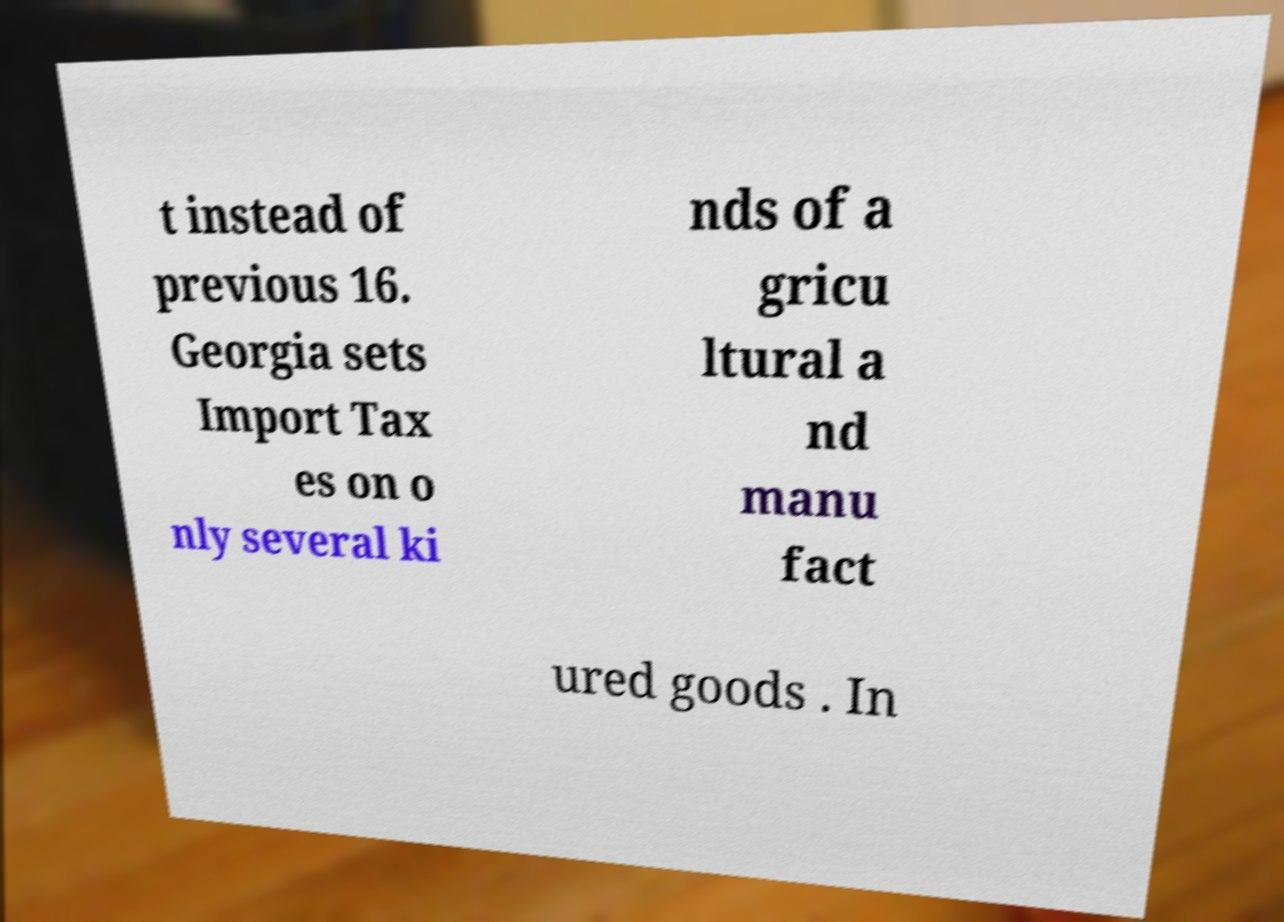Can you accurately transcribe the text from the provided image for me? t instead of previous 16. Georgia sets Import Tax es on o nly several ki nds of a gricu ltural a nd manu fact ured goods . In 